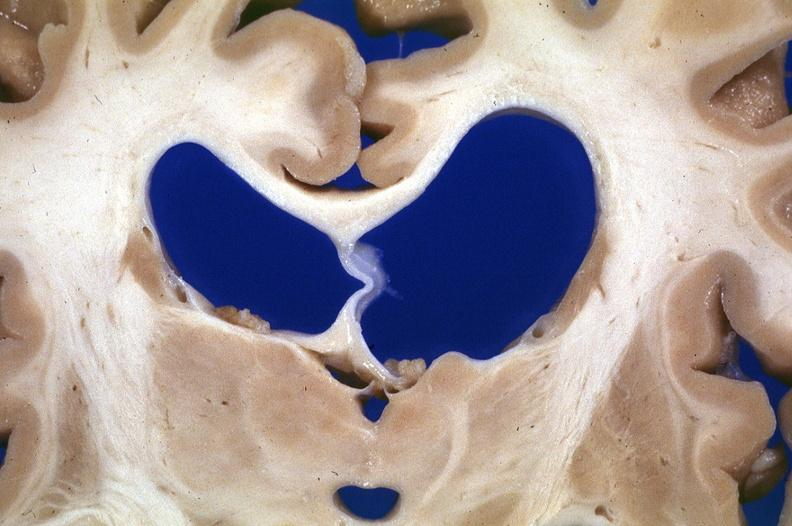s nervous present?
Answer the question using a single word or phrase. Yes 